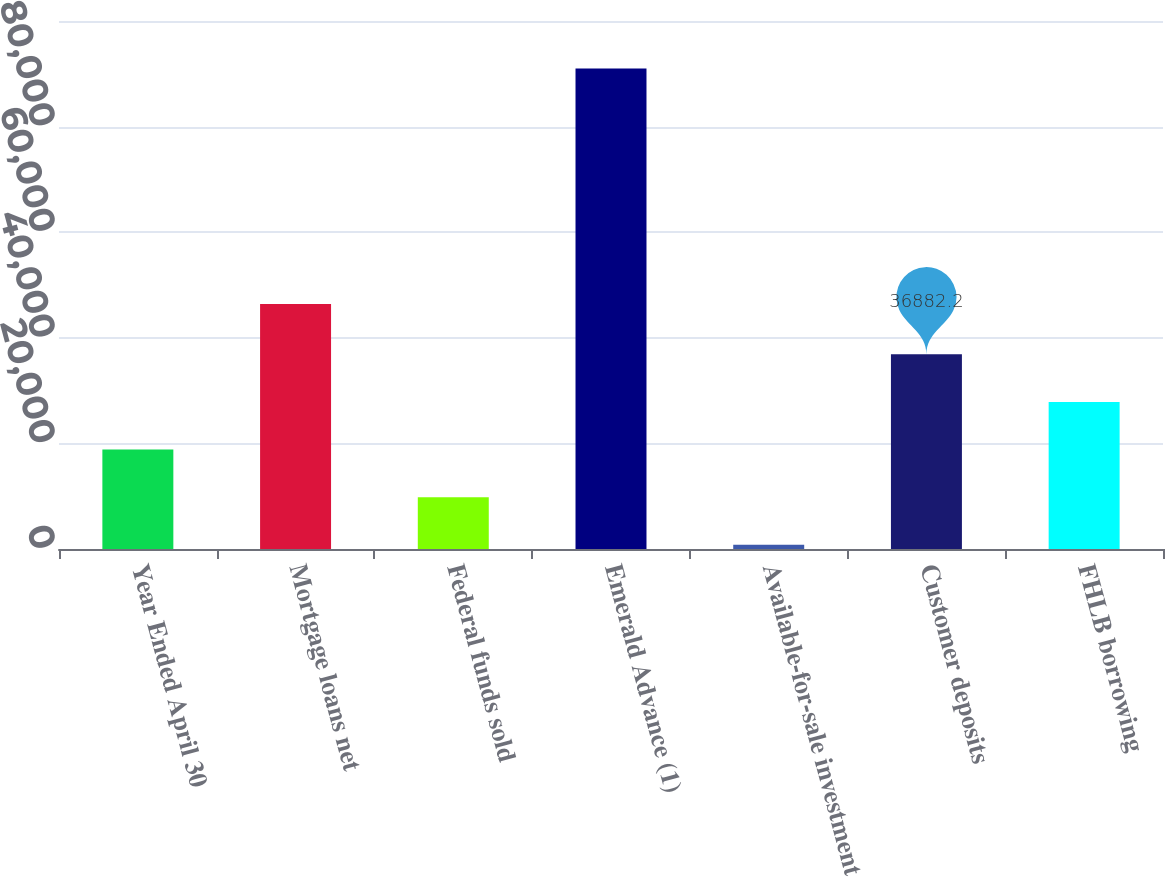Convert chart to OTSL. <chart><loc_0><loc_0><loc_500><loc_500><bar_chart><fcel>Year Ended April 30<fcel>Mortgage loans net<fcel>Federal funds sold<fcel>Emerald Advance (1)<fcel>Available-for-sale investment<fcel>Customer deposits<fcel>FHLB borrowing<nl><fcel>18836.6<fcel>46396<fcel>9813.8<fcel>91019<fcel>791<fcel>36882.2<fcel>27859.4<nl></chart> 